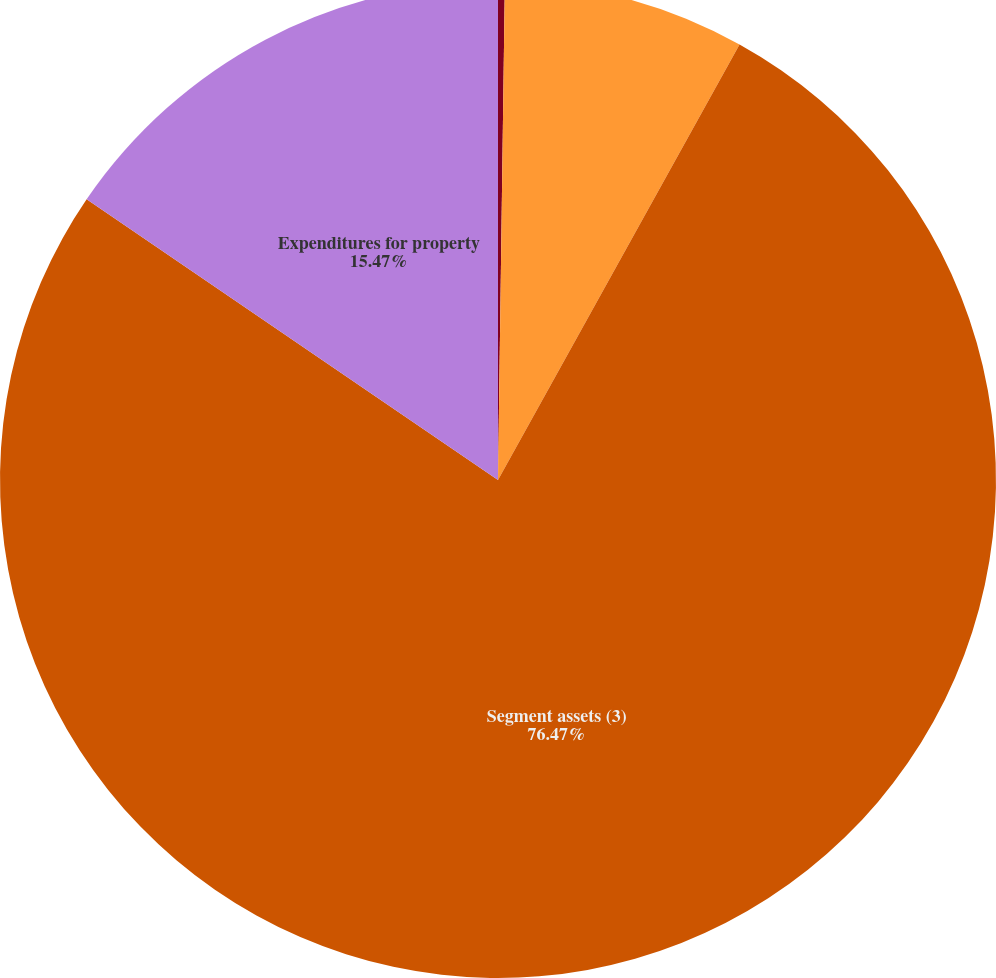<chart> <loc_0><loc_0><loc_500><loc_500><pie_chart><fcel>Total net sales<fcel>Depreciation and amortization<fcel>Segment assets (3)<fcel>Expenditures for property<nl><fcel>0.22%<fcel>7.84%<fcel>76.47%<fcel>15.47%<nl></chart> 